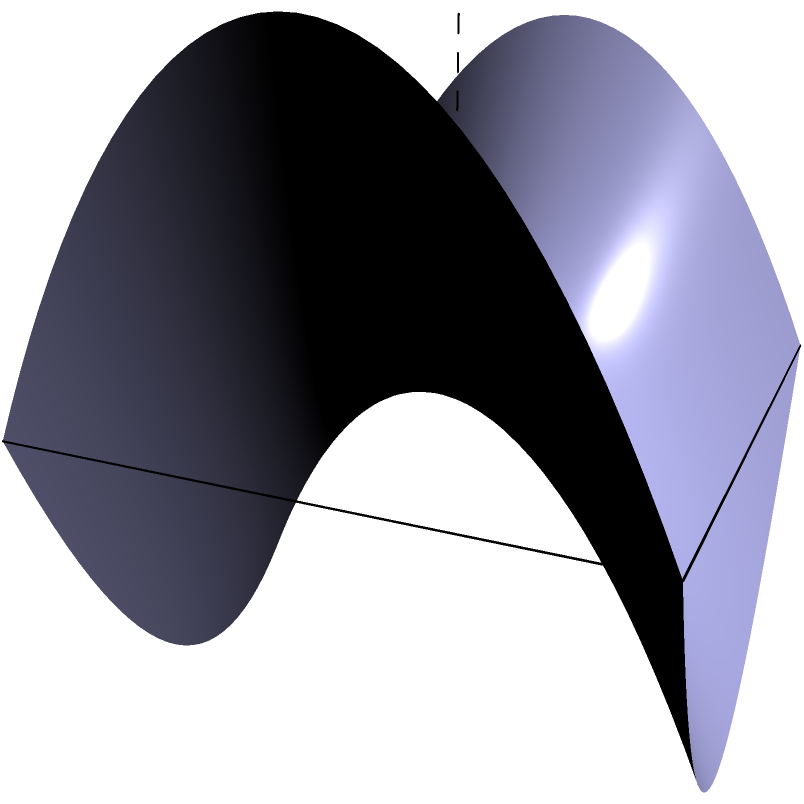As a pediatrician who appreciates precision in medical treatments, consider a saddle-shaped surface described by the equation $z = x^2 - y^2$. Two points A(1, 1, 0) and B(-1, -1, 0) are marked on this surface. What is the shape of the shortest path (geodesic) between these two points when viewed from above? To understand the shape of the shortest path (geodesic) between two points on a saddle-shaped surface, let's break it down step-by-step:

1) The surface is described by the equation $z = x^2 - y^2$, which is a hyperbolic paraboloid or saddle shape.

2) Points A(1, 1, 0) and B(-1, -1, 0) are on opposite corners of the surface when viewed from above.

3) In Euclidean geometry, the shortest path between two points is a straight line. However, on curved surfaces in non-Euclidean geometry, this is not always the case.

4) On a saddle-shaped surface, geodesics (shortest paths) tend to curve away from the center of the saddle.

5) The geodesic between A and B will follow the curvature of the surface, bending outward to minimize the distance traveled along the surface.

6) When viewed from above (i.e., projected onto the xy-plane), this curved path will appear as a convex curve bowing outward from the straight line connecting A and B.

7) The exact shape of this curve depends on the specific parameters of the surface, but it will generally resemble a portion of a hyperbola.

8) This curved path allows the geodesic to take advantage of the surface's geometry, finding the most efficient route between the two points while adhering to the surface's shape.

Just as in pediatrics where the most direct approach isn't always the best for a child's treatment, the shortest path on this surface isn't a straight line but a carefully curved path that respects the surface's unique geometry.
Answer: Convex curve (hyperbola-like) 